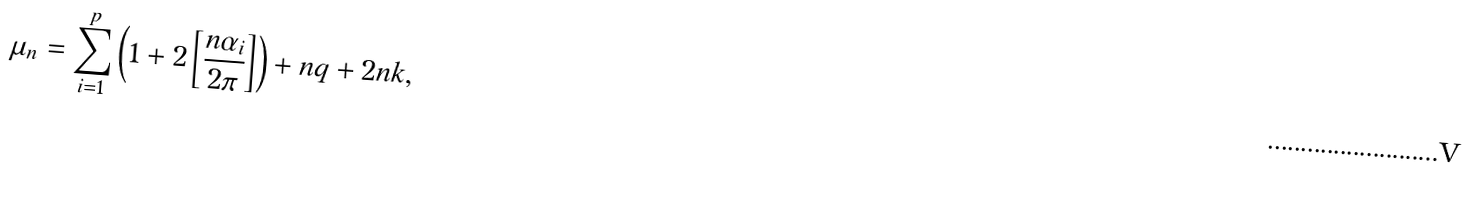Convert formula to latex. <formula><loc_0><loc_0><loc_500><loc_500>\mu _ { n } = \sum _ { i = 1 } ^ { p } \left ( 1 + 2 \left [ \frac { n \alpha _ { i } } { 2 \pi } \right ] \right ) + n q + 2 n k ,</formula> 